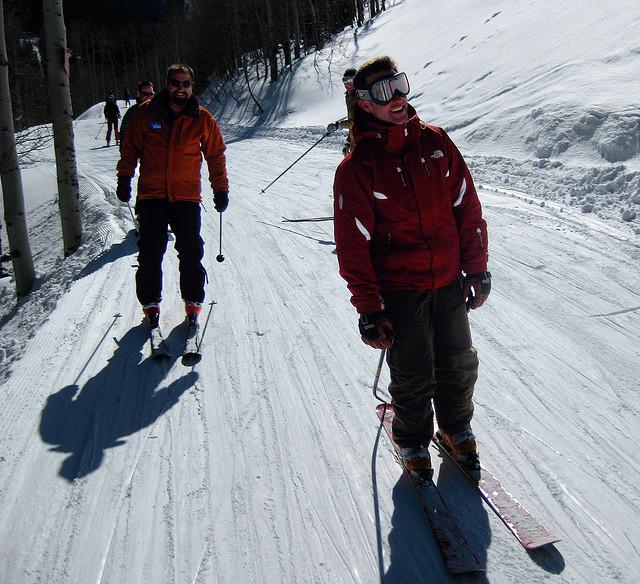Where are they cross country skiing?
Keep it brief. Colorado. Is it spring?
Answer briefly. No. Are they standing still?
Be succinct. No. 